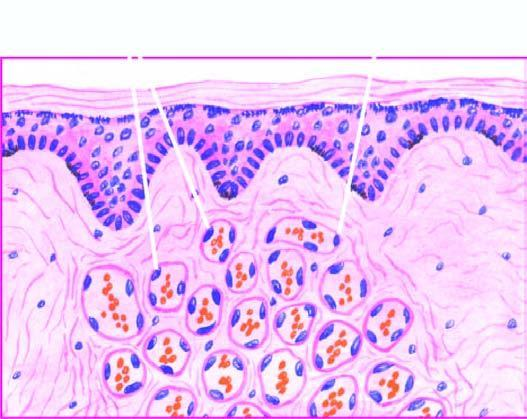what are there lined by plump endothelial cells and containing blood?
Answer the question using a single word or phrase. Capillaries 